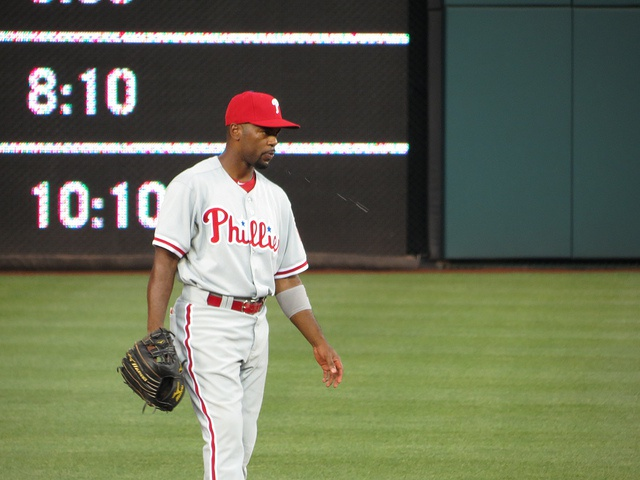Describe the objects in this image and their specific colors. I can see people in black, lightgray, gray, and darkgray tones and baseball glove in black, gray, olive, and darkgreen tones in this image. 